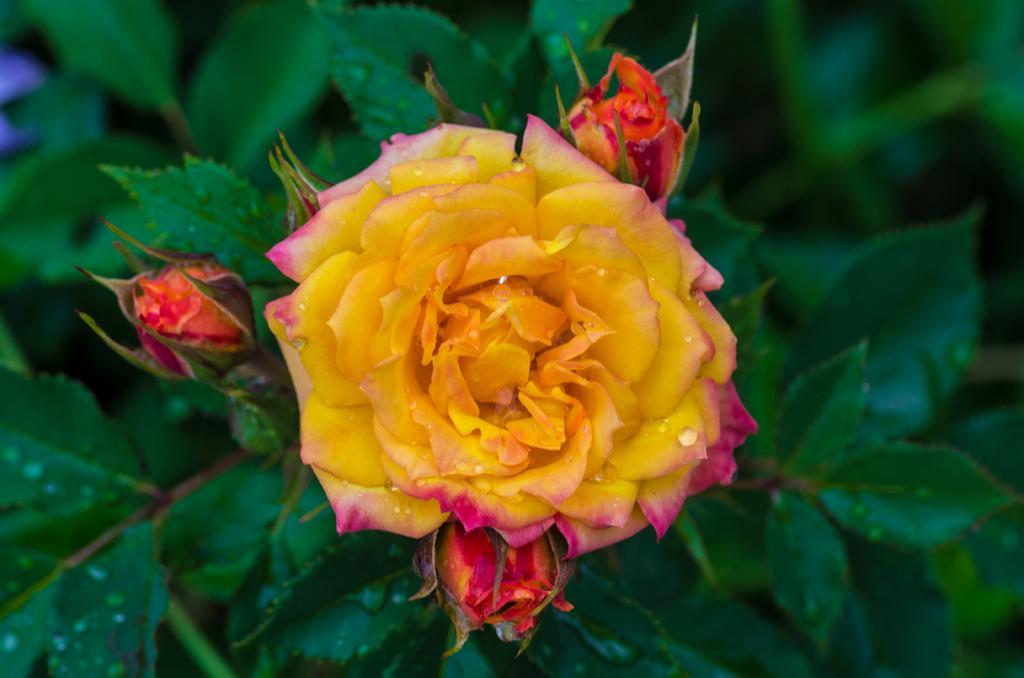Describe this image in one or two sentences. In this image we can see rose flower. Also there are buds on the plant. 